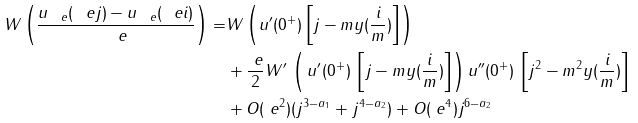<formula> <loc_0><loc_0><loc_500><loc_500>W \left ( \frac { u _ { \ e } ( \ e j ) - u _ { \ e } ( \ e i ) } { \ e } \right ) = & W \left ( u ^ { \prime } ( 0 ^ { + } ) \left [ j - m y ( \frac { i } { m } ) \right ] \right ) \\ & + \frac { \ e } { 2 } W ^ { \prime } \, \left ( \, u ^ { \prime } ( 0 ^ { + } ) \, \left [ j - m y ( \frac { i } { m } ) \right ] \right ) u ^ { \prime \prime } ( 0 ^ { + } ) \, \left [ j ^ { 2 } - m ^ { 2 } y ( \frac { i } { m } ) \right ] \\ & + O ( \ e ^ { 2 } ) ( j ^ { 3 - a _ { 1 } } + j ^ { 4 - a _ { 2 } } ) + O ( \ e ^ { 4 } ) j ^ { 6 - a _ { 2 } }</formula> 